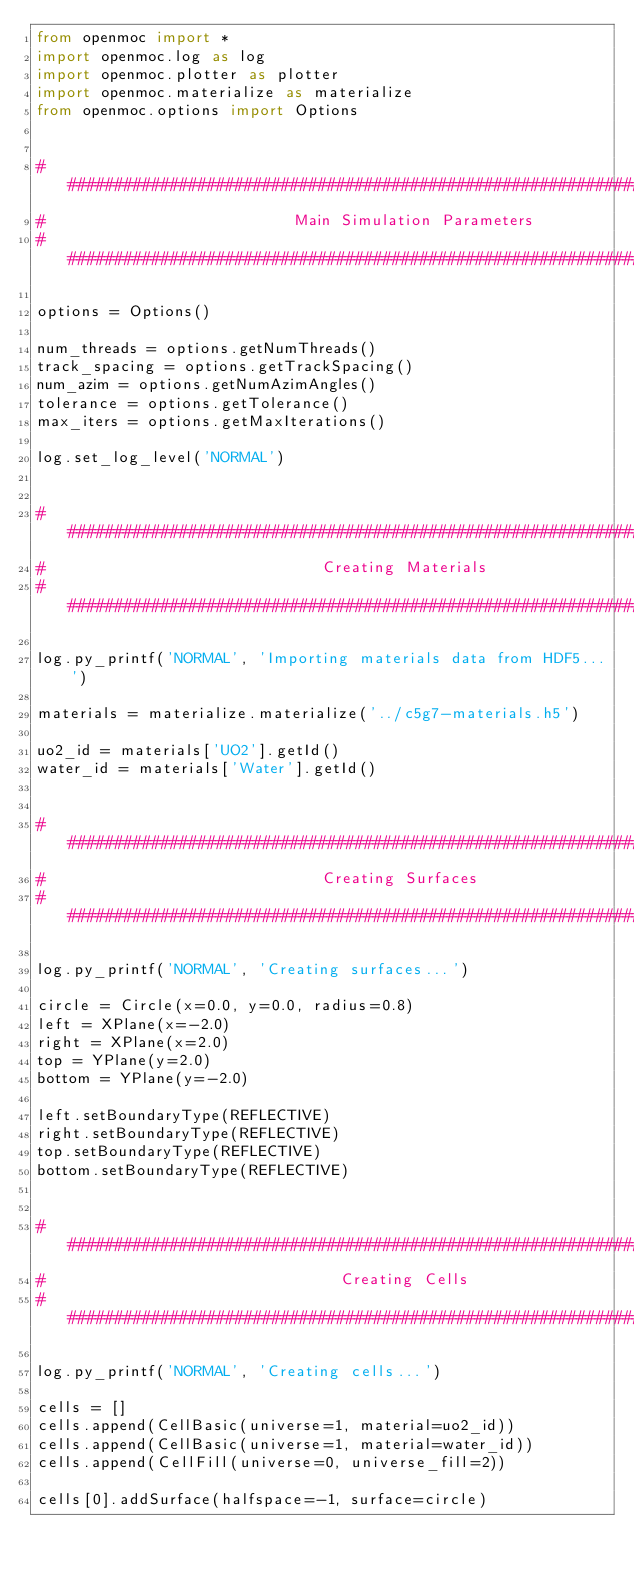Convert code to text. <code><loc_0><loc_0><loc_500><loc_500><_Python_>from openmoc import *
import openmoc.log as log
import openmoc.plotter as plotter
import openmoc.materialize as materialize
from openmoc.options import Options


###############################################################################
#                           Main Simulation Parameters 
###############################################################################

options = Options()

num_threads = options.getNumThreads()
track_spacing = options.getTrackSpacing()
num_azim = options.getNumAzimAngles()
tolerance = options.getTolerance()
max_iters = options.getMaxIterations()

log.set_log_level('NORMAL')


###############################################################################
#                              Creating Materials
###############################################################################

log.py_printf('NORMAL', 'Importing materials data from HDF5...')

materials = materialize.materialize('../c5g7-materials.h5')

uo2_id = materials['UO2'].getId()
water_id = materials['Water'].getId()


###############################################################################
#                              Creating Surfaces
###############################################################################

log.py_printf('NORMAL', 'Creating surfaces...')

circle = Circle(x=0.0, y=0.0, radius=0.8)
left = XPlane(x=-2.0)
right = XPlane(x=2.0)
top = YPlane(y=2.0)
bottom = YPlane(y=-2.0)

left.setBoundaryType(REFLECTIVE)
right.setBoundaryType(REFLECTIVE)
top.setBoundaryType(REFLECTIVE)
bottom.setBoundaryType(REFLECTIVE)


###############################################################################
#                                Creating Cells
###############################################################################

log.py_printf('NORMAL', 'Creating cells...')

cells = []
cells.append(CellBasic(universe=1, material=uo2_id))
cells.append(CellBasic(universe=1, material=water_id))
cells.append(CellFill(universe=0, universe_fill=2))

cells[0].addSurface(halfspace=-1, surface=circle)</code> 